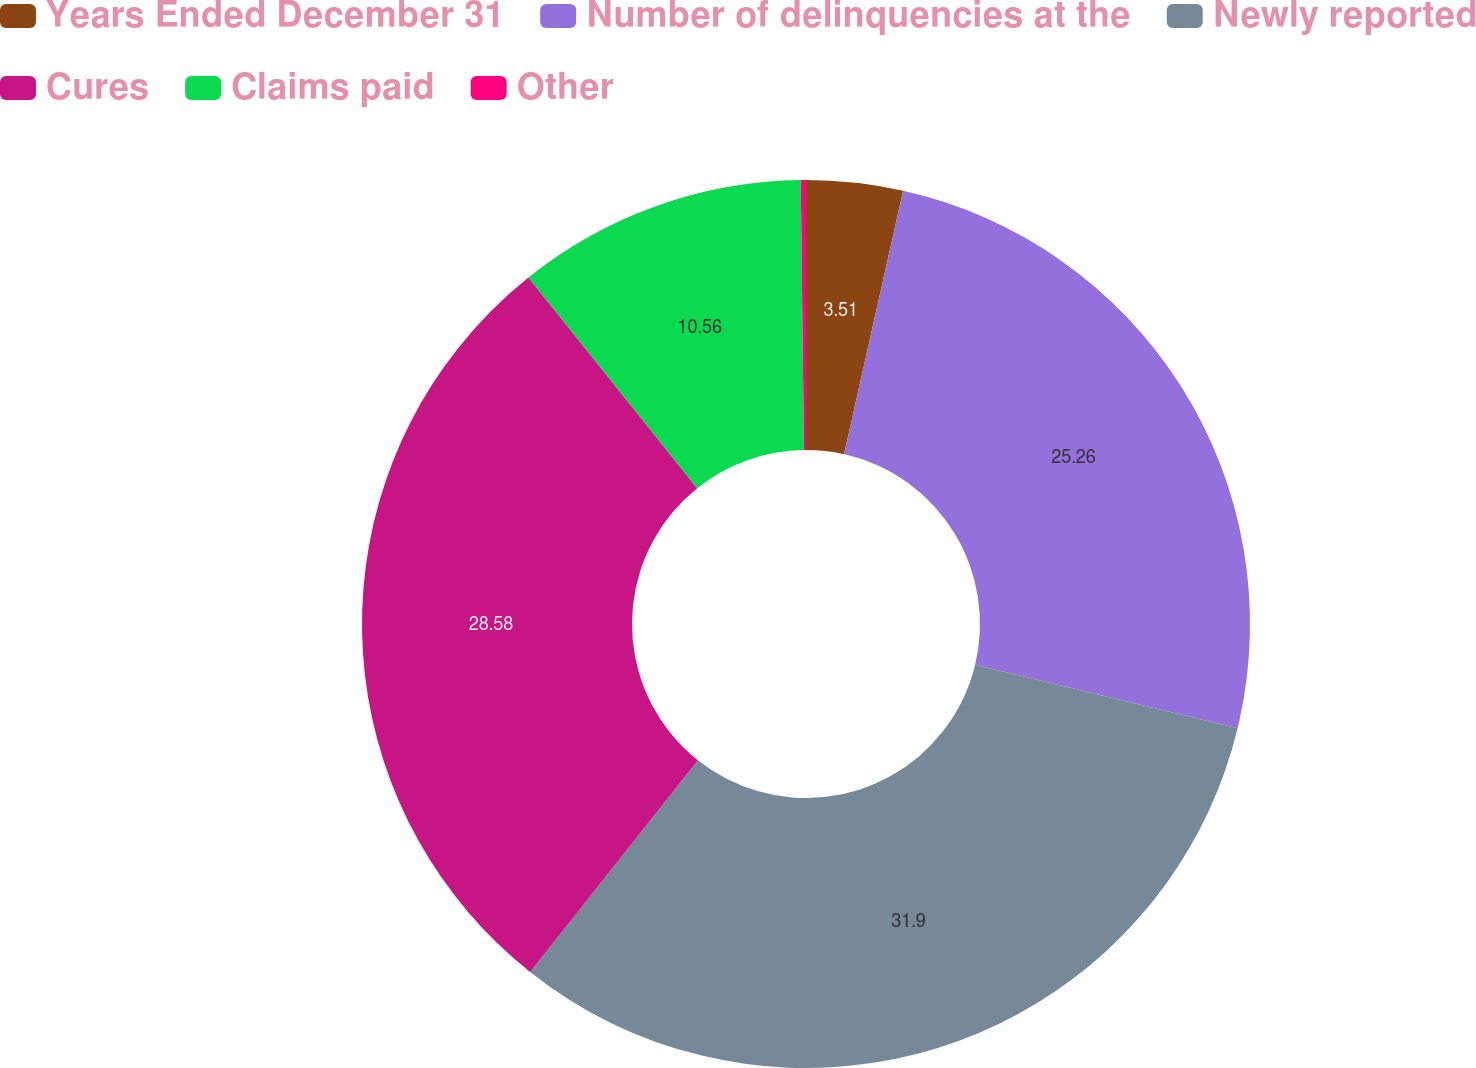<chart> <loc_0><loc_0><loc_500><loc_500><pie_chart><fcel>Years Ended December 31<fcel>Number of delinquencies at the<fcel>Newly reported<fcel>Cures<fcel>Claims paid<fcel>Other<nl><fcel>3.51%<fcel>25.26%<fcel>31.9%<fcel>28.58%<fcel>10.56%<fcel>0.19%<nl></chart> 